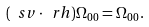<formula> <loc_0><loc_0><loc_500><loc_500>( \ s v \cdot \ r h ) \Omega _ { 0 0 } = \Omega _ { 0 0 } .</formula> 